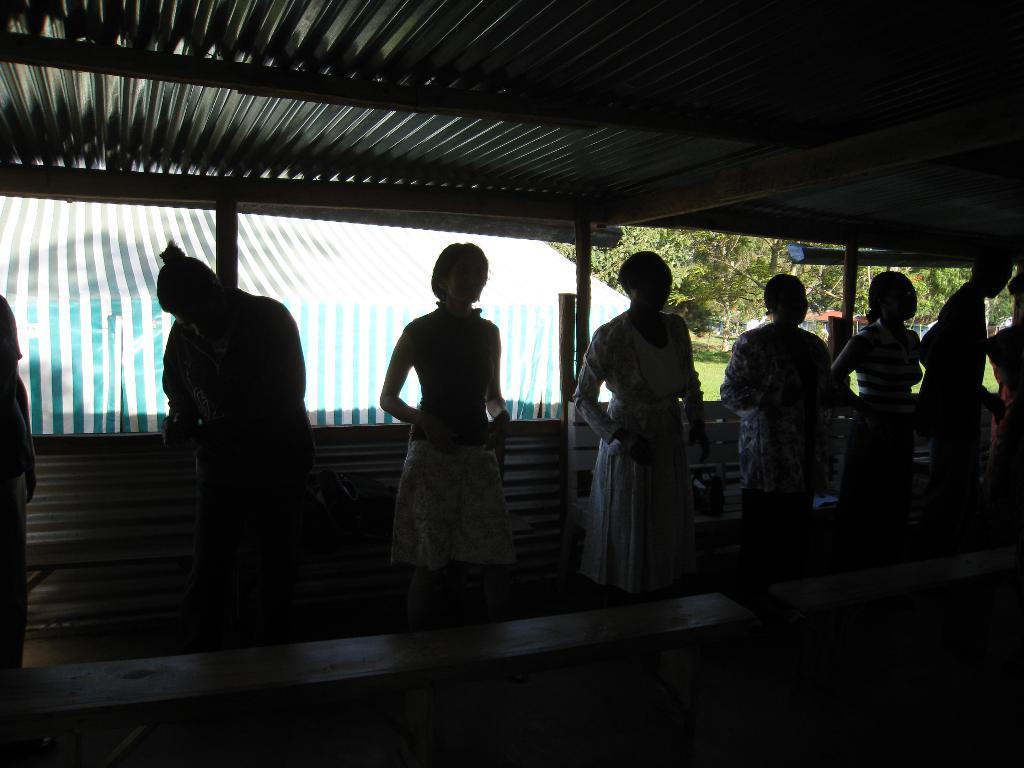How many people are in the group visible in the image? There is a group of people standing in the image, but the exact number cannot be determined from the provided facts. What is located behind the group of people? There appears to be a bench behind the people. What can be seen near the group of people? There is a stall visible in the image. What type of vegetation is on the right side of the stall? Trees are present on the right side of the stall. What type of texture does the potato have in the image? There is no potato present in the image, so it is not possible to determine its texture. 